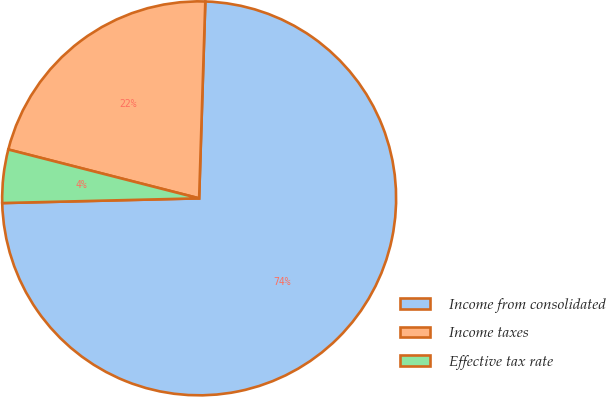<chart> <loc_0><loc_0><loc_500><loc_500><pie_chart><fcel>Income from consolidated<fcel>Income taxes<fcel>Effective tax rate<nl><fcel>74.12%<fcel>21.51%<fcel>4.37%<nl></chart> 